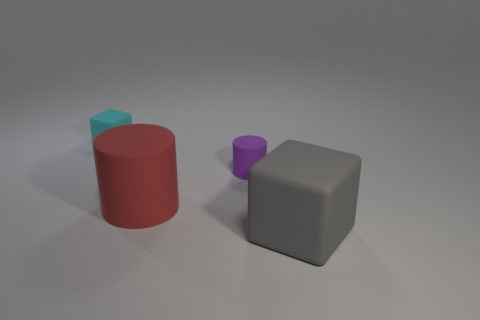How many other things are there of the same material as the cyan block?
Ensure brevity in your answer.  3. What number of matte cubes are to the left of the gray matte thing to the right of the small purple matte cylinder behind the big cylinder?
Provide a succinct answer. 1. How many rubber things are either big green cylinders or large gray objects?
Your answer should be very brief. 1. What is the size of the block on the right side of the thing behind the tiny purple rubber cylinder?
Your answer should be compact. Large. There is a cube in front of the cyan block; is its color the same as the block behind the purple cylinder?
Offer a terse response. No. What is the color of the matte thing that is both right of the large red object and on the left side of the big gray matte block?
Give a very brief answer. Purple. Is the purple cylinder made of the same material as the small cube?
Provide a short and direct response. Yes. How many small objects are either cylinders or red matte cylinders?
Offer a terse response. 1. Are there any other things that have the same shape as the red thing?
Offer a very short reply. Yes. Is there anything else that is the same size as the gray thing?
Ensure brevity in your answer.  Yes. 